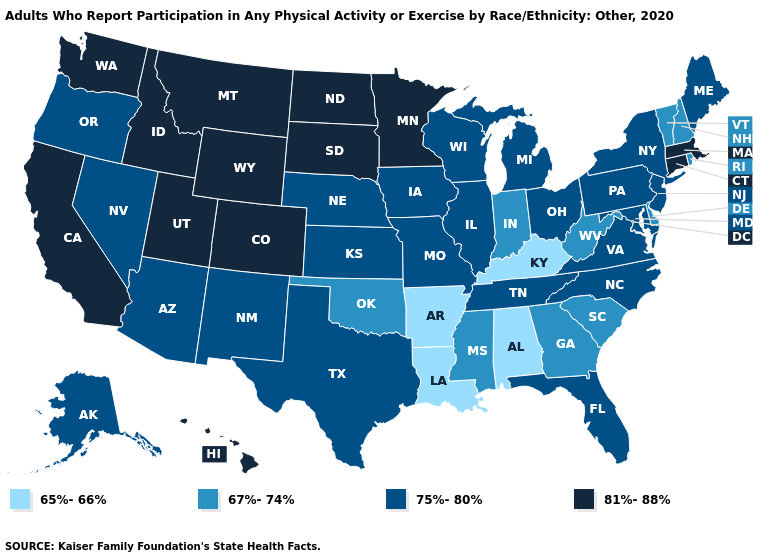Name the states that have a value in the range 75%-80%?
Give a very brief answer. Alaska, Arizona, Florida, Illinois, Iowa, Kansas, Maine, Maryland, Michigan, Missouri, Nebraska, Nevada, New Jersey, New Mexico, New York, North Carolina, Ohio, Oregon, Pennsylvania, Tennessee, Texas, Virginia, Wisconsin. Name the states that have a value in the range 67%-74%?
Write a very short answer. Delaware, Georgia, Indiana, Mississippi, New Hampshire, Oklahoma, Rhode Island, South Carolina, Vermont, West Virginia. Name the states that have a value in the range 65%-66%?
Short answer required. Alabama, Arkansas, Kentucky, Louisiana. Name the states that have a value in the range 65%-66%?
Keep it brief. Alabama, Arkansas, Kentucky, Louisiana. Does North Carolina have the same value as Maine?
Be succinct. Yes. Name the states that have a value in the range 65%-66%?
Be succinct. Alabama, Arkansas, Kentucky, Louisiana. Does New Jersey have the lowest value in the USA?
Write a very short answer. No. What is the value of Wyoming?
Give a very brief answer. 81%-88%. What is the value of Louisiana?
Write a very short answer. 65%-66%. What is the lowest value in states that border Arkansas?
Write a very short answer. 65%-66%. What is the lowest value in states that border Utah?
Short answer required. 75%-80%. Which states have the highest value in the USA?
Write a very short answer. California, Colorado, Connecticut, Hawaii, Idaho, Massachusetts, Minnesota, Montana, North Dakota, South Dakota, Utah, Washington, Wyoming. Among the states that border West Virginia , does Virginia have the highest value?
Short answer required. Yes. Among the states that border Tennessee , does Alabama have the highest value?
Give a very brief answer. No. What is the highest value in states that border Kentucky?
Be succinct. 75%-80%. 